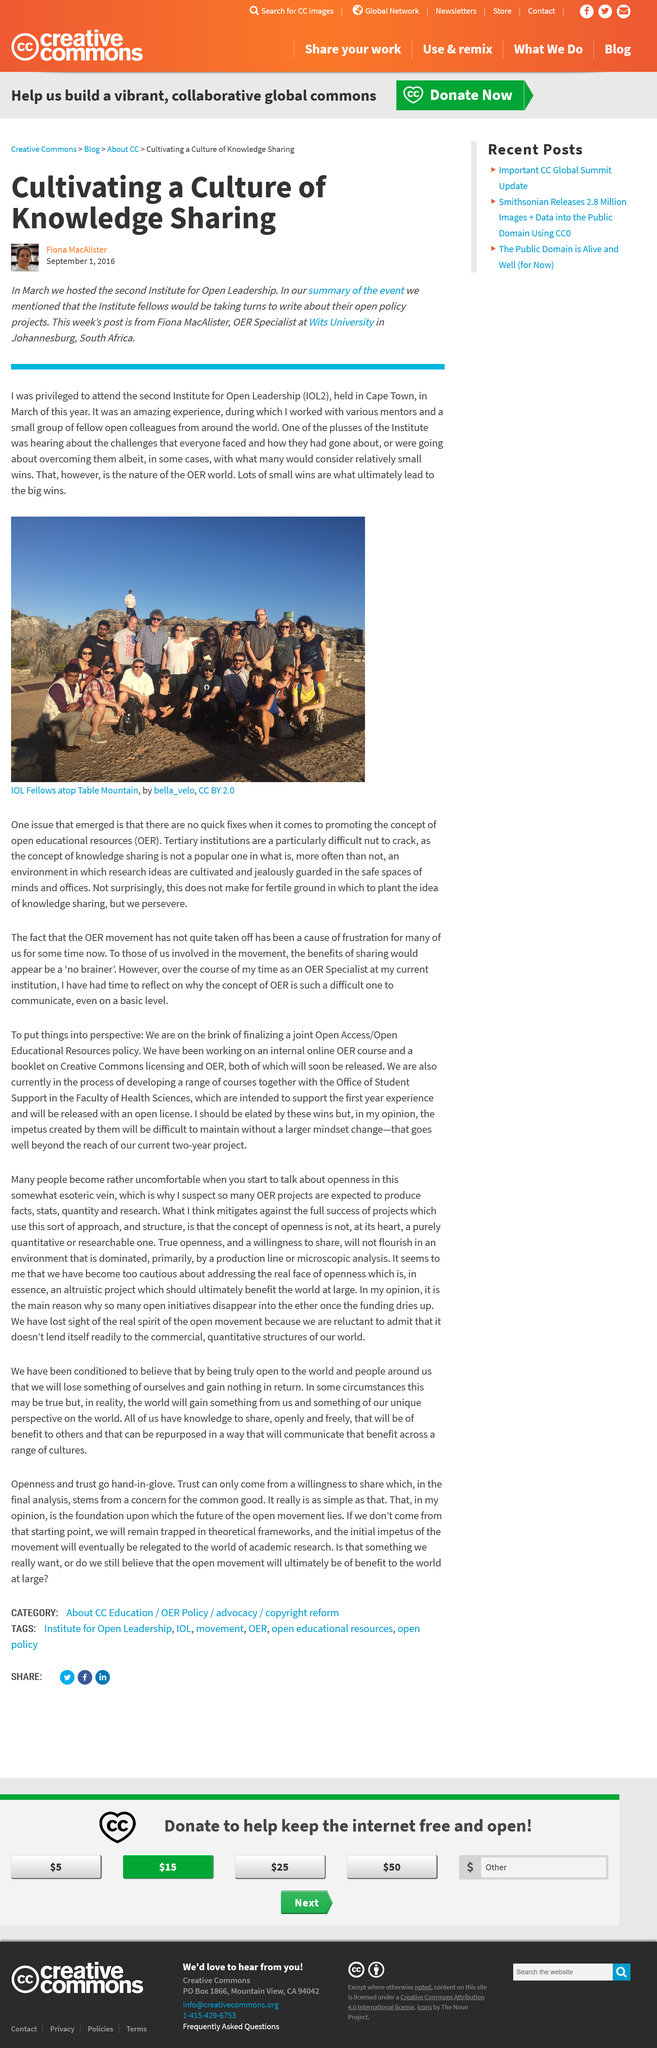Specify some key components in this picture. Fiona MacAlister is employed as an OER Specialist at Wits University. The Second Institute for Open Leadership (IOL2) took place in March 2016 in Cape Town. Wits University is located in the city of Johannesburg. 